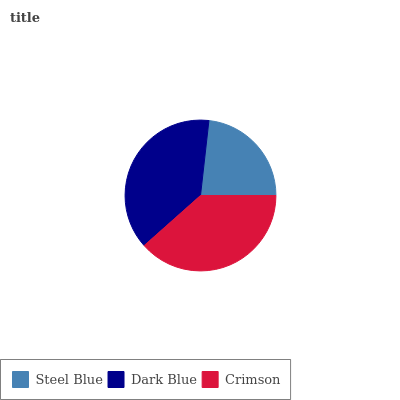Is Steel Blue the minimum?
Answer yes or no. Yes. Is Crimson the maximum?
Answer yes or no. Yes. Is Dark Blue the minimum?
Answer yes or no. No. Is Dark Blue the maximum?
Answer yes or no. No. Is Dark Blue greater than Steel Blue?
Answer yes or no. Yes. Is Steel Blue less than Dark Blue?
Answer yes or no. Yes. Is Steel Blue greater than Dark Blue?
Answer yes or no. No. Is Dark Blue less than Steel Blue?
Answer yes or no. No. Is Dark Blue the high median?
Answer yes or no. Yes. Is Dark Blue the low median?
Answer yes or no. Yes. Is Crimson the high median?
Answer yes or no. No. Is Steel Blue the low median?
Answer yes or no. No. 